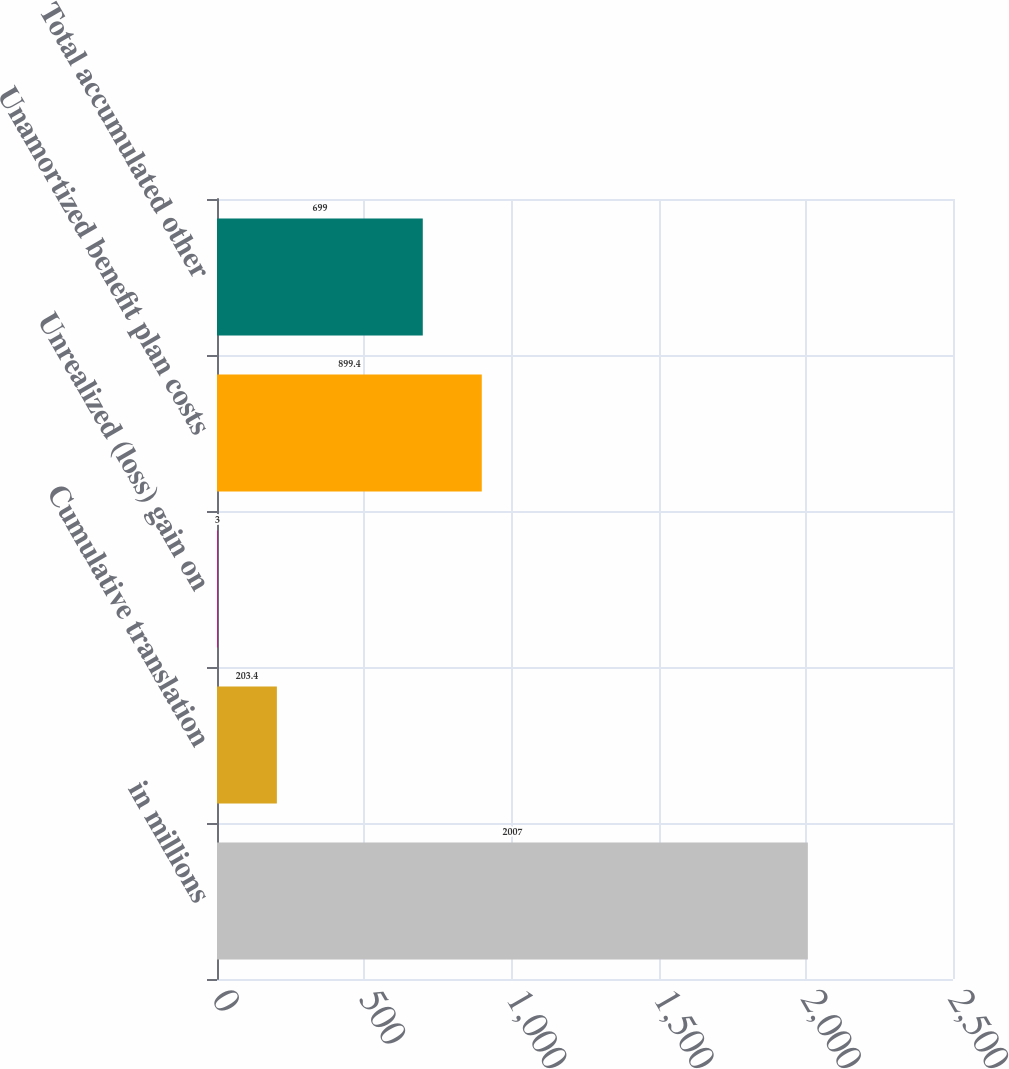Convert chart to OTSL. <chart><loc_0><loc_0><loc_500><loc_500><bar_chart><fcel>in millions<fcel>Cumulative translation<fcel>Unrealized (loss) gain on<fcel>Unamortized benefit plan costs<fcel>Total accumulated other<nl><fcel>2007<fcel>203.4<fcel>3<fcel>899.4<fcel>699<nl></chart> 